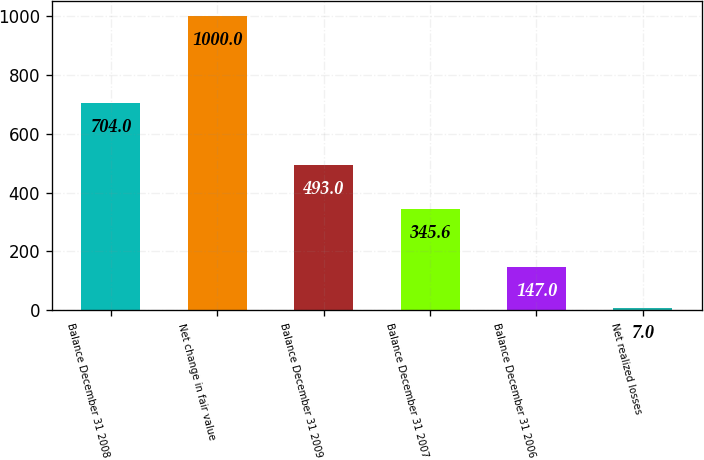Convert chart. <chart><loc_0><loc_0><loc_500><loc_500><bar_chart><fcel>Balance December 31 2008<fcel>Net change in fair value<fcel>Balance December 31 2009<fcel>Balance December 31 2007<fcel>Balance December 31 2006<fcel>Net realized losses<nl><fcel>704<fcel>1000<fcel>493<fcel>345.6<fcel>147<fcel>7<nl></chart> 